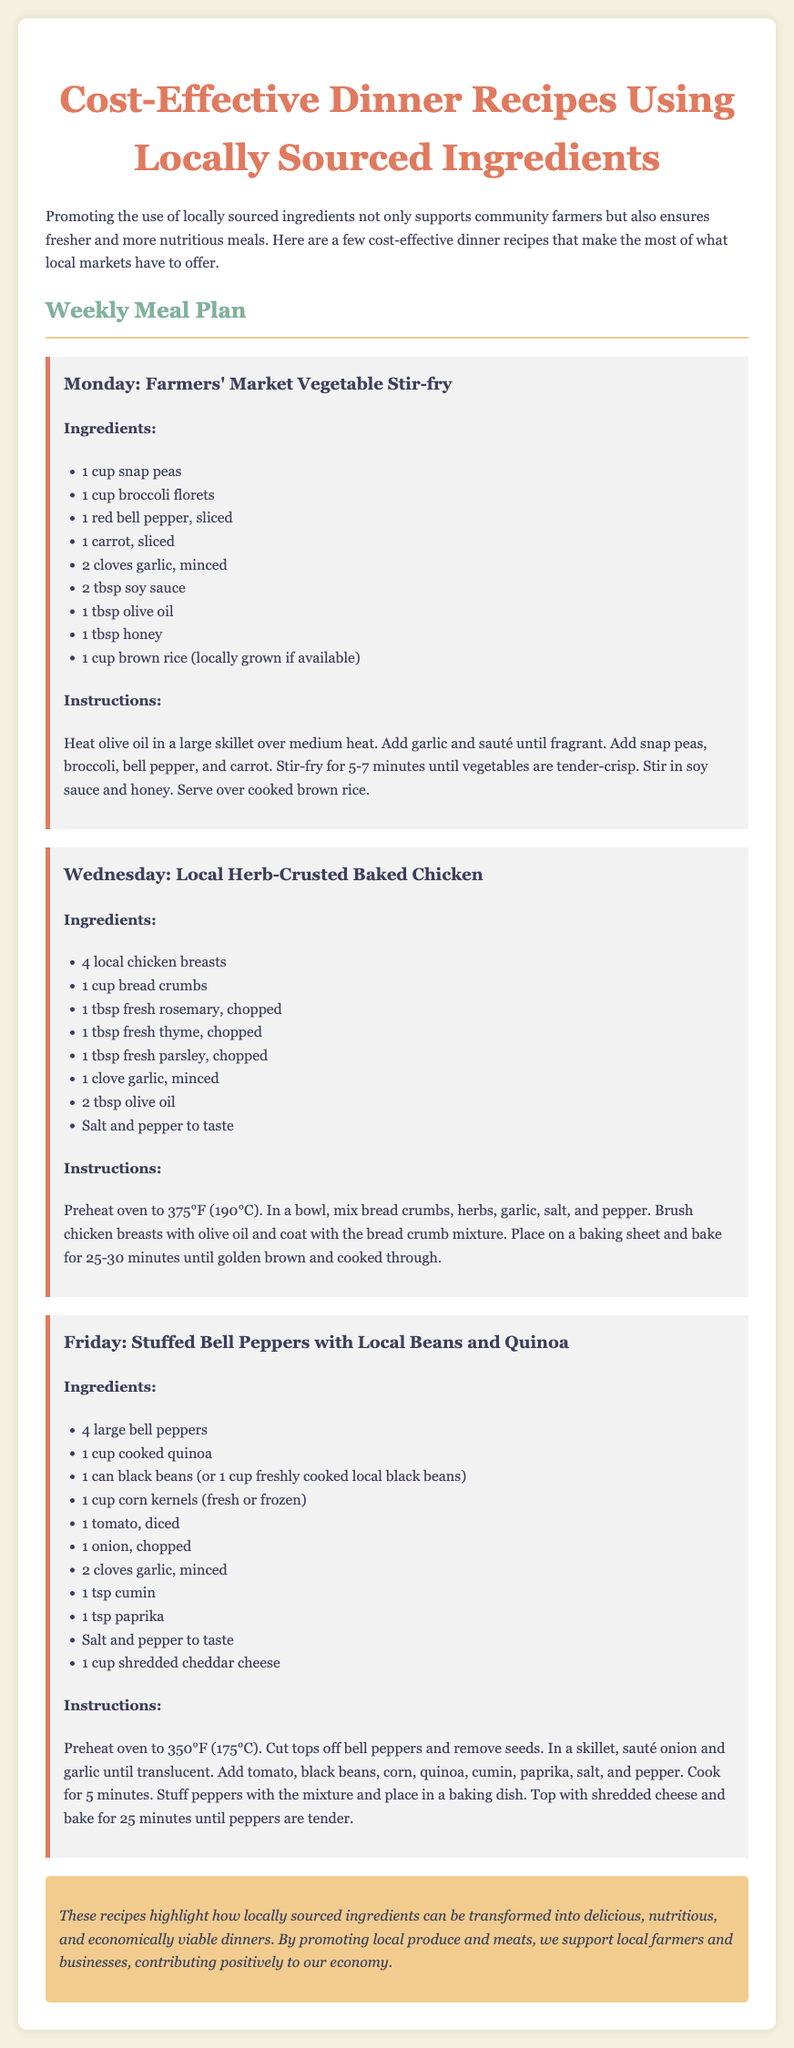what is the title of the document? The title is the main heading given at the top of the document.
Answer: Cost-Effective Dinner Recipes Using Locally Sourced Ingredients how many meals are included in the weekly meal plan? The document lists three specific meals for the week.
Answer: 3 what is one ingredient used in the Farmers' Market Vegetable Stir-fry? The ingredient is specifically listed in the ingredients section for that meal.
Answer: Snap peas what temperature should the oven be preheated to for the Local Herb-Crusted Baked Chicken? The temperature is mentioned in the cooking instructions for that particular meal.
Answer: 375°F which day includes Stuffed Bell Peppers with Local Beans and Quinoa? The day is specified in the heading of the meal description.
Answer: Friday what is the cooking method used for the Farmers' Market Vegetable Stir-fry? The method is referred to in the instructions for that meal preparation.
Answer: Stir-fry how many chicken breasts are needed for the Local Herb-Crusted Baked Chicken? The number of chicken breasts is listed in the ingredients section.
Answer: 4 what is the main type of cheese used in the Stuffed Bell Peppers? The cheese type is clearly mentioned in the ingredients list for that meal.
Answer: Cheddar cheese what is a benefit of using locally sourced ingredients mentioned in the conclusion? The benefit is discussed in the concluding remarks about community support and freshness.
Answer: Supports local farmers 